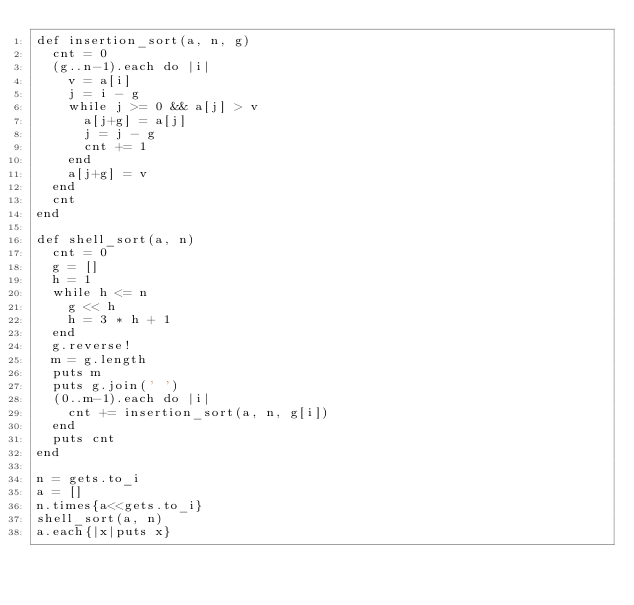Convert code to text. <code><loc_0><loc_0><loc_500><loc_500><_Ruby_>def insertion_sort(a, n, g)
  cnt = 0
  (g..n-1).each do |i|
    v = a[i]
    j = i - g
    while j >= 0 && a[j] > v
      a[j+g] = a[j]
      j = j - g
      cnt += 1
    end
    a[j+g] = v
  end
  cnt
end

def shell_sort(a, n)
  cnt = 0
  g = []
  h = 1
  while h <= n
    g << h
    h = 3 * h + 1
  end
  g.reverse!
  m = g.length
  puts m
  puts g.join(' ')
  (0..m-1).each do |i|
    cnt += insertion_sort(a, n, g[i])
  end
  puts cnt
end

n = gets.to_i
a = []
n.times{a<<gets.to_i}
shell_sort(a, n)
a.each{|x|puts x}
</code> 